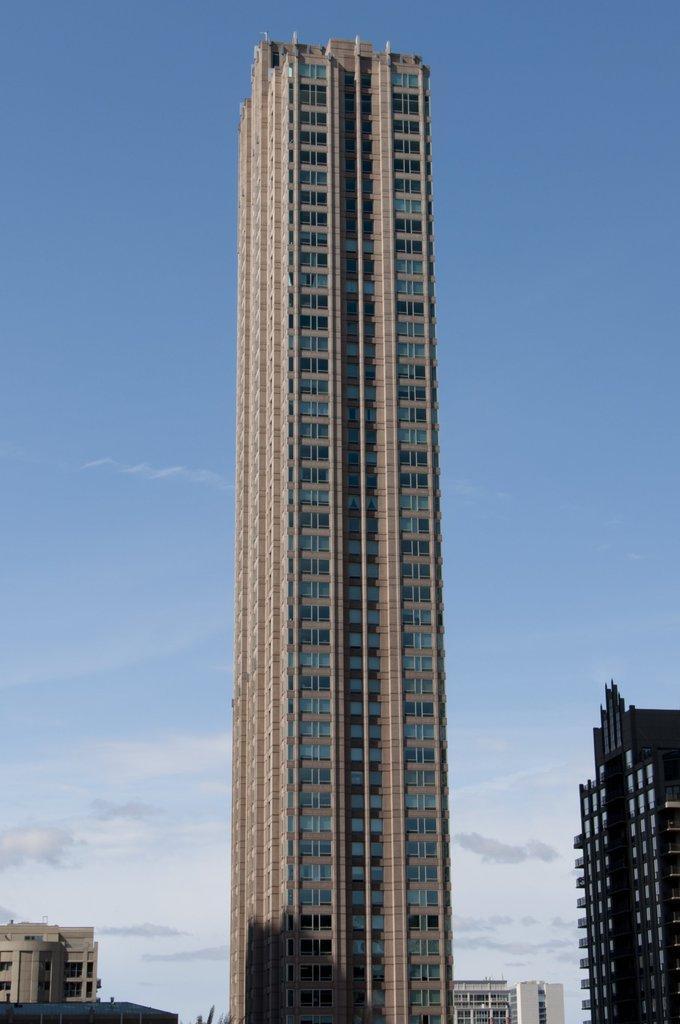Can you describe this image briefly? We can see buildings and sky with clouds. 